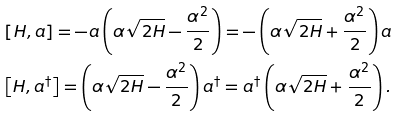<formula> <loc_0><loc_0><loc_500><loc_500>& \left [ H , a \right ] = - a \left ( \alpha \sqrt { 2 H } - \frac { \alpha ^ { 2 } } { 2 } \right ) = - \left ( \alpha \sqrt { 2 H } + \frac { \alpha ^ { 2 } } { 2 } \right ) a \\ & \left [ H , a ^ { \dagger } \right ] = \left ( \alpha \sqrt { 2 H } - \frac { \alpha ^ { 2 } } { 2 } \right ) a ^ { \dagger } = a ^ { \dagger } \left ( \alpha \sqrt { 2 H } + \frac { \alpha ^ { 2 } } { 2 } \right ) . \\</formula> 